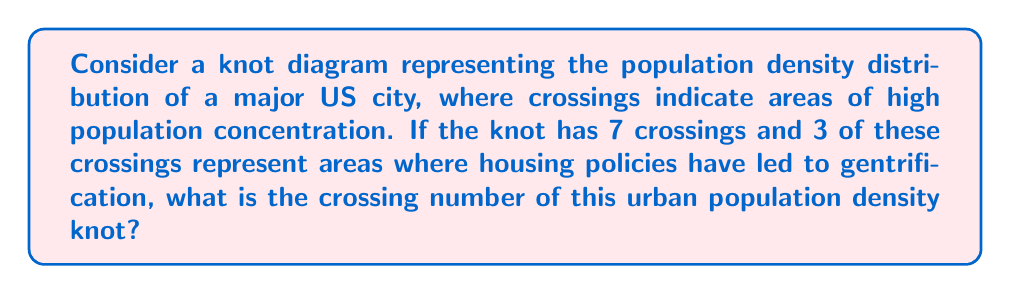Could you help me with this problem? To determine the crossing number of this knot representing urban population density, we need to follow these steps:

1. Understand the concept of crossing number:
   The crossing number of a knot is the minimum number of crossings that occur in any projection of the knot onto a plane.

2. Analyze the given information:
   - The knot diagram has 7 crossings in total.
   - 3 of these crossings represent areas affected by gentrification due to housing policies.

3. Consider the impact of housing policies:
   In this context, the crossings related to gentrification are essential features of the urban landscape and cannot be eliminated or simplified.

4. Evaluate the remaining crossings:
   The other 4 crossings (7 - 3 = 4) represent high population concentration areas not directly linked to gentrification.

5. Determine if any simplification is possible:
   Without additional information about the specific layout of the knot, we cannot assume that any of the remaining 4 crossings can be eliminated through knot simplification techniques.

6. Calculate the crossing number:
   Since we cannot eliminate any crossings based on the given information, the crossing number is equal to the total number of crossings in the diagram.

   Crossing number = Total crossings = 7

Therefore, the crossing number of this urban population density knot is 7.
Answer: 7 